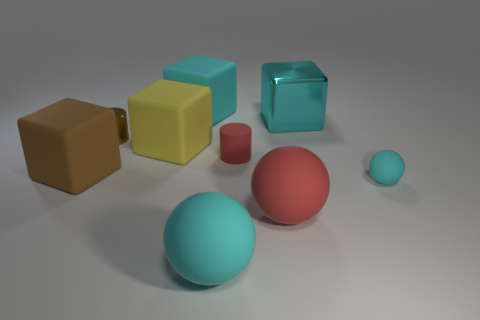Subtract 2 cubes. How many cubes are left? 2 Subtract all large balls. How many balls are left? 1 Subtract all yellow blocks. How many blocks are left? 3 Add 1 tiny gray matte objects. How many objects exist? 10 Subtract all purple blocks. Subtract all green cylinders. How many blocks are left? 4 Subtract all cylinders. How many objects are left? 7 Add 2 large red matte balls. How many large red matte balls are left? 3 Add 6 big brown shiny cylinders. How many big brown shiny cylinders exist? 6 Subtract 0 purple balls. How many objects are left? 9 Subtract all large cyan balls. Subtract all tiny cyan matte objects. How many objects are left? 7 